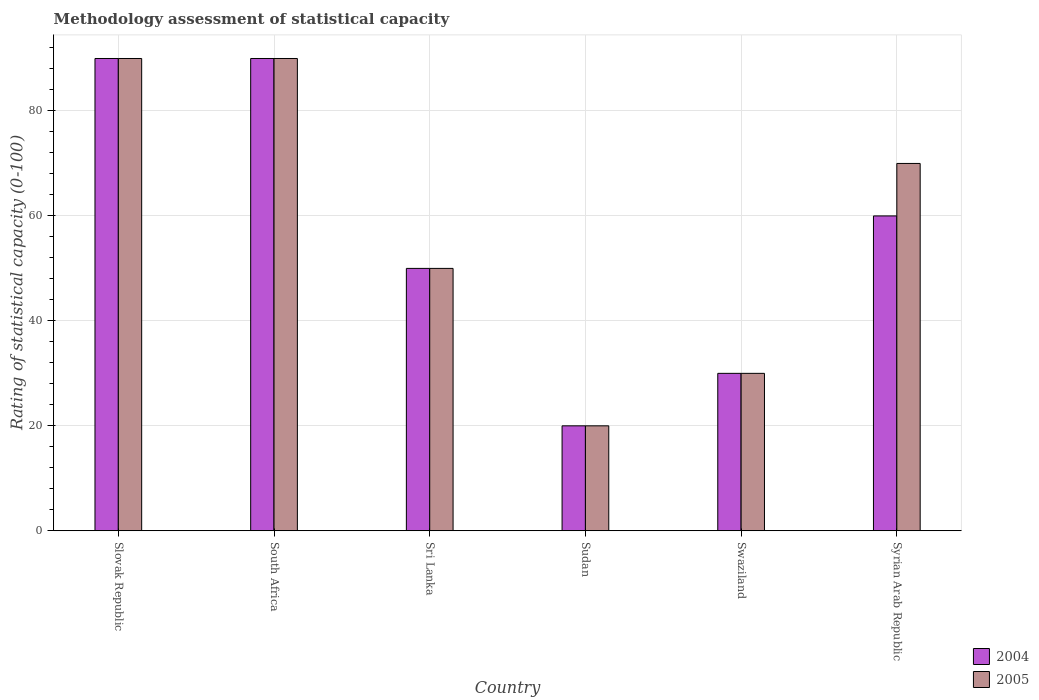How many different coloured bars are there?
Provide a succinct answer. 2. How many groups of bars are there?
Keep it short and to the point. 6. Are the number of bars per tick equal to the number of legend labels?
Provide a short and direct response. Yes. Are the number of bars on each tick of the X-axis equal?
Your response must be concise. Yes. What is the label of the 1st group of bars from the left?
Keep it short and to the point. Slovak Republic. In how many cases, is the number of bars for a given country not equal to the number of legend labels?
Your answer should be compact. 0. What is the rating of statistical capacity in 2005 in Sri Lanka?
Offer a terse response. 50. In which country was the rating of statistical capacity in 2005 maximum?
Keep it short and to the point. Slovak Republic. In which country was the rating of statistical capacity in 2005 minimum?
Offer a very short reply. Sudan. What is the total rating of statistical capacity in 2004 in the graph?
Your answer should be compact. 340. What is the average rating of statistical capacity in 2004 per country?
Your answer should be compact. 56.67. What is the difference between the rating of statistical capacity of/in 2004 and rating of statistical capacity of/in 2005 in South Africa?
Offer a terse response. 0. In how many countries, is the rating of statistical capacity in 2004 greater than 44?
Make the answer very short. 4. What is the ratio of the rating of statistical capacity in 2005 in Slovak Republic to that in Sudan?
Provide a short and direct response. 4.5. Is the rating of statistical capacity in 2005 in Sri Lanka less than that in Sudan?
Keep it short and to the point. No. Is the difference between the rating of statistical capacity in 2004 in Slovak Republic and Swaziland greater than the difference between the rating of statistical capacity in 2005 in Slovak Republic and Swaziland?
Ensure brevity in your answer.  No. What is the difference between the highest and the second highest rating of statistical capacity in 2005?
Your answer should be very brief. 20. What is the difference between the highest and the lowest rating of statistical capacity in 2004?
Give a very brief answer. 70. In how many countries, is the rating of statistical capacity in 2004 greater than the average rating of statistical capacity in 2004 taken over all countries?
Give a very brief answer. 3. Is the sum of the rating of statistical capacity in 2005 in Slovak Republic and Sudan greater than the maximum rating of statistical capacity in 2004 across all countries?
Your answer should be compact. Yes. What does the 2nd bar from the left in Swaziland represents?
Your response must be concise. 2005. How many bars are there?
Give a very brief answer. 12. What is the difference between two consecutive major ticks on the Y-axis?
Your answer should be very brief. 20. Does the graph contain any zero values?
Your answer should be compact. No. How many legend labels are there?
Give a very brief answer. 2. What is the title of the graph?
Your answer should be compact. Methodology assessment of statistical capacity. What is the label or title of the X-axis?
Keep it short and to the point. Country. What is the label or title of the Y-axis?
Provide a short and direct response. Rating of statistical capacity (0-100). What is the Rating of statistical capacity (0-100) of 2004 in Slovak Republic?
Offer a terse response. 90. What is the Rating of statistical capacity (0-100) of 2005 in Slovak Republic?
Provide a short and direct response. 90. What is the Rating of statistical capacity (0-100) in 2004 in Sri Lanka?
Ensure brevity in your answer.  50. What is the Rating of statistical capacity (0-100) of 2004 in Sudan?
Offer a terse response. 20. What is the Rating of statistical capacity (0-100) of 2005 in Swaziland?
Provide a short and direct response. 30. What is the Rating of statistical capacity (0-100) of 2004 in Syrian Arab Republic?
Your answer should be compact. 60. What is the Rating of statistical capacity (0-100) in 2005 in Syrian Arab Republic?
Offer a terse response. 70. Across all countries, what is the maximum Rating of statistical capacity (0-100) of 2004?
Your answer should be compact. 90. Across all countries, what is the maximum Rating of statistical capacity (0-100) in 2005?
Your response must be concise. 90. Across all countries, what is the minimum Rating of statistical capacity (0-100) in 2004?
Give a very brief answer. 20. Across all countries, what is the minimum Rating of statistical capacity (0-100) of 2005?
Your answer should be compact. 20. What is the total Rating of statistical capacity (0-100) in 2004 in the graph?
Your response must be concise. 340. What is the total Rating of statistical capacity (0-100) of 2005 in the graph?
Your response must be concise. 350. What is the difference between the Rating of statistical capacity (0-100) in 2004 in Slovak Republic and that in South Africa?
Make the answer very short. 0. What is the difference between the Rating of statistical capacity (0-100) in 2004 in Slovak Republic and that in Sudan?
Your response must be concise. 70. What is the difference between the Rating of statistical capacity (0-100) of 2005 in Slovak Republic and that in Syrian Arab Republic?
Give a very brief answer. 20. What is the difference between the Rating of statistical capacity (0-100) of 2004 in South Africa and that in Sudan?
Offer a terse response. 70. What is the difference between the Rating of statistical capacity (0-100) in 2005 in South Africa and that in Sudan?
Offer a very short reply. 70. What is the difference between the Rating of statistical capacity (0-100) of 2004 in South Africa and that in Swaziland?
Offer a terse response. 60. What is the difference between the Rating of statistical capacity (0-100) in 2005 in South Africa and that in Swaziland?
Your answer should be very brief. 60. What is the difference between the Rating of statistical capacity (0-100) of 2004 in Sri Lanka and that in Sudan?
Provide a short and direct response. 30. What is the difference between the Rating of statistical capacity (0-100) of 2005 in Sri Lanka and that in Syrian Arab Republic?
Offer a terse response. -20. What is the difference between the Rating of statistical capacity (0-100) of 2005 in Sudan and that in Swaziland?
Your answer should be compact. -10. What is the difference between the Rating of statistical capacity (0-100) of 2005 in Sudan and that in Syrian Arab Republic?
Keep it short and to the point. -50. What is the difference between the Rating of statistical capacity (0-100) in 2004 in Swaziland and that in Syrian Arab Republic?
Make the answer very short. -30. What is the difference between the Rating of statistical capacity (0-100) of 2004 in Slovak Republic and the Rating of statistical capacity (0-100) of 2005 in Sri Lanka?
Your answer should be very brief. 40. What is the difference between the Rating of statistical capacity (0-100) in 2004 in Slovak Republic and the Rating of statistical capacity (0-100) in 2005 in Swaziland?
Make the answer very short. 60. What is the difference between the Rating of statistical capacity (0-100) of 2004 in Slovak Republic and the Rating of statistical capacity (0-100) of 2005 in Syrian Arab Republic?
Offer a terse response. 20. What is the difference between the Rating of statistical capacity (0-100) of 2004 in South Africa and the Rating of statistical capacity (0-100) of 2005 in Syrian Arab Republic?
Make the answer very short. 20. What is the difference between the Rating of statistical capacity (0-100) of 2004 in Sri Lanka and the Rating of statistical capacity (0-100) of 2005 in Swaziland?
Provide a short and direct response. 20. What is the difference between the Rating of statistical capacity (0-100) in 2004 in Sudan and the Rating of statistical capacity (0-100) in 2005 in Syrian Arab Republic?
Keep it short and to the point. -50. What is the average Rating of statistical capacity (0-100) in 2004 per country?
Give a very brief answer. 56.67. What is the average Rating of statistical capacity (0-100) of 2005 per country?
Offer a terse response. 58.33. What is the difference between the Rating of statistical capacity (0-100) of 2004 and Rating of statistical capacity (0-100) of 2005 in Slovak Republic?
Ensure brevity in your answer.  0. What is the difference between the Rating of statistical capacity (0-100) in 2004 and Rating of statistical capacity (0-100) in 2005 in South Africa?
Offer a terse response. 0. What is the difference between the Rating of statistical capacity (0-100) in 2004 and Rating of statistical capacity (0-100) in 2005 in Sudan?
Your answer should be very brief. 0. What is the difference between the Rating of statistical capacity (0-100) of 2004 and Rating of statistical capacity (0-100) of 2005 in Syrian Arab Republic?
Offer a terse response. -10. What is the ratio of the Rating of statistical capacity (0-100) in 2005 in Slovak Republic to that in South Africa?
Offer a terse response. 1. What is the ratio of the Rating of statistical capacity (0-100) in 2004 in Slovak Republic to that in Sri Lanka?
Give a very brief answer. 1.8. What is the ratio of the Rating of statistical capacity (0-100) in 2004 in Slovak Republic to that in Sudan?
Provide a short and direct response. 4.5. What is the ratio of the Rating of statistical capacity (0-100) of 2004 in Slovak Republic to that in Syrian Arab Republic?
Provide a short and direct response. 1.5. What is the ratio of the Rating of statistical capacity (0-100) of 2005 in Slovak Republic to that in Syrian Arab Republic?
Offer a very short reply. 1.29. What is the ratio of the Rating of statistical capacity (0-100) in 2004 in South Africa to that in Sri Lanka?
Provide a succinct answer. 1.8. What is the ratio of the Rating of statistical capacity (0-100) in 2005 in South Africa to that in Sri Lanka?
Your response must be concise. 1.8. What is the ratio of the Rating of statistical capacity (0-100) in 2004 in South Africa to that in Sudan?
Your response must be concise. 4.5. What is the ratio of the Rating of statistical capacity (0-100) in 2005 in South Africa to that in Syrian Arab Republic?
Your answer should be compact. 1.29. What is the ratio of the Rating of statistical capacity (0-100) in 2004 in Sri Lanka to that in Sudan?
Ensure brevity in your answer.  2.5. What is the ratio of the Rating of statistical capacity (0-100) of 2004 in Sri Lanka to that in Swaziland?
Offer a terse response. 1.67. What is the ratio of the Rating of statistical capacity (0-100) in 2005 in Sri Lanka to that in Syrian Arab Republic?
Provide a succinct answer. 0.71. What is the ratio of the Rating of statistical capacity (0-100) of 2004 in Sudan to that in Swaziland?
Offer a terse response. 0.67. What is the ratio of the Rating of statistical capacity (0-100) in 2005 in Sudan to that in Swaziland?
Offer a terse response. 0.67. What is the ratio of the Rating of statistical capacity (0-100) of 2004 in Sudan to that in Syrian Arab Republic?
Ensure brevity in your answer.  0.33. What is the ratio of the Rating of statistical capacity (0-100) of 2005 in Sudan to that in Syrian Arab Republic?
Your answer should be very brief. 0.29. What is the ratio of the Rating of statistical capacity (0-100) of 2004 in Swaziland to that in Syrian Arab Republic?
Make the answer very short. 0.5. What is the ratio of the Rating of statistical capacity (0-100) of 2005 in Swaziland to that in Syrian Arab Republic?
Make the answer very short. 0.43. What is the difference between the highest and the second highest Rating of statistical capacity (0-100) of 2005?
Ensure brevity in your answer.  0. What is the difference between the highest and the lowest Rating of statistical capacity (0-100) of 2005?
Provide a short and direct response. 70. 